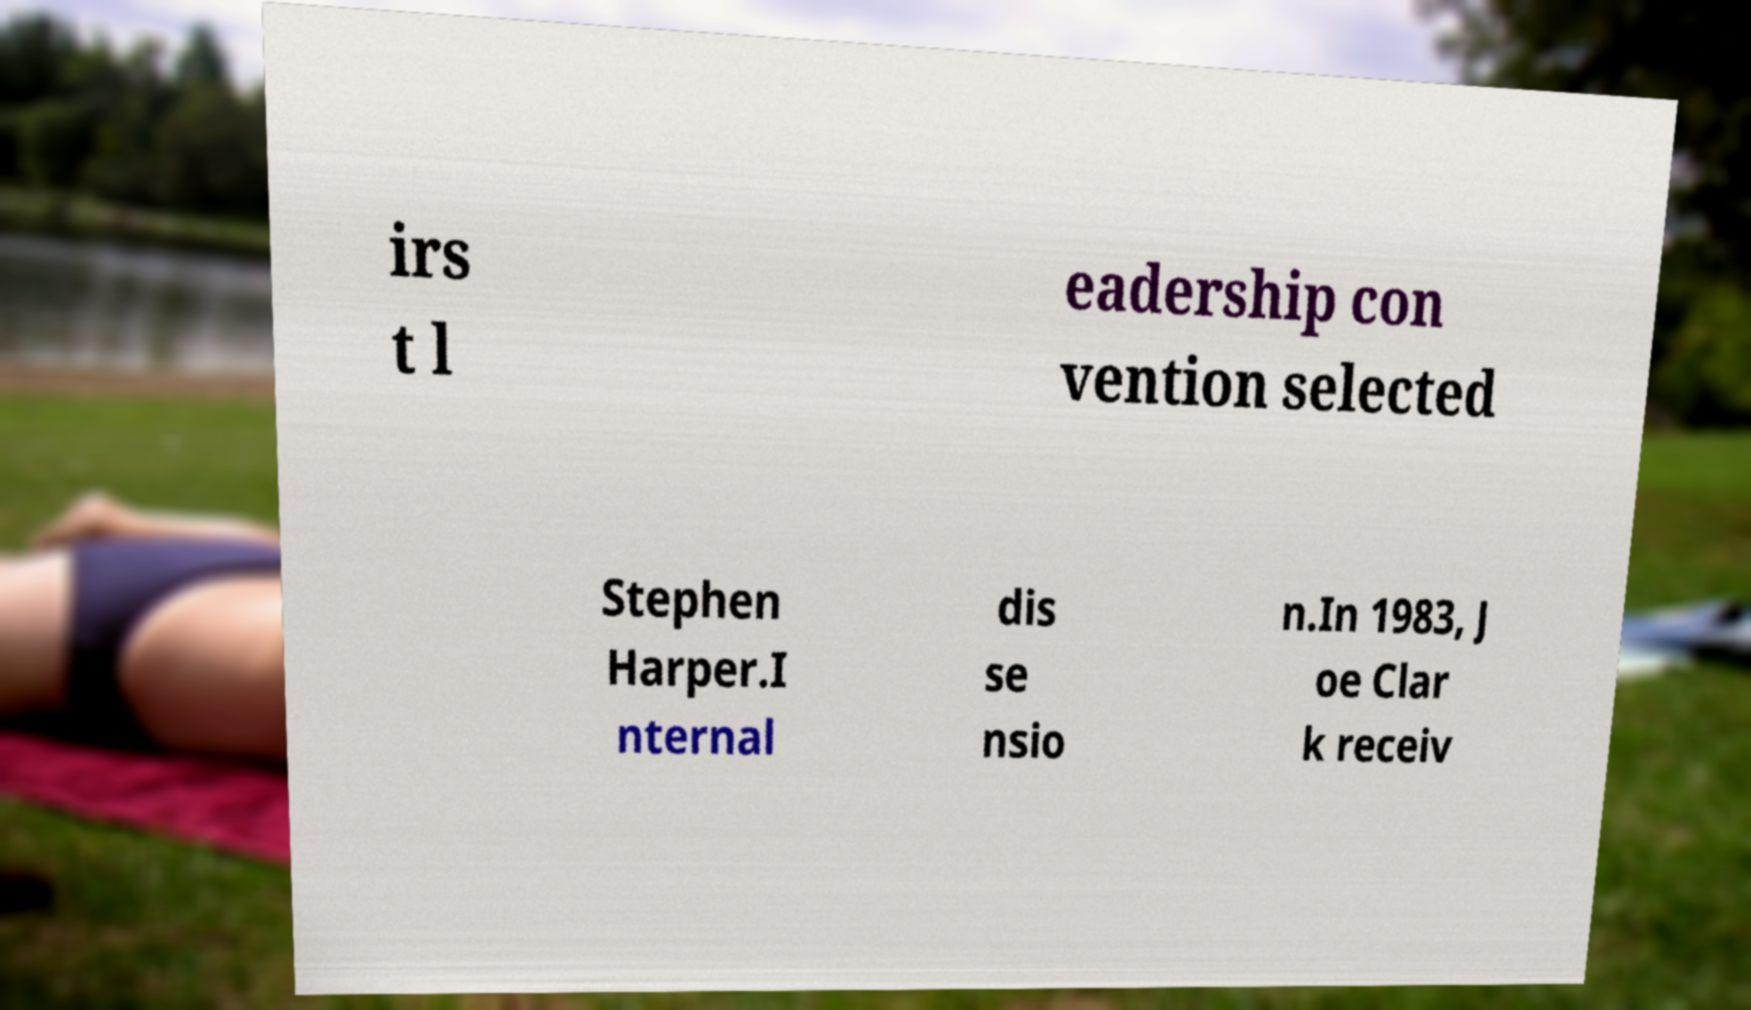Could you extract and type out the text from this image? irs t l eadership con vention selected Stephen Harper.I nternal dis se nsio n.In 1983, J oe Clar k receiv 